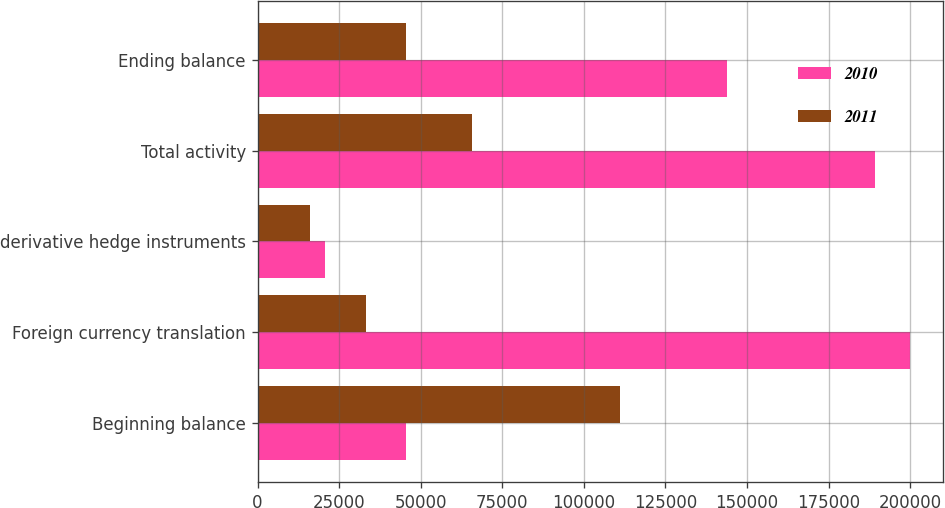Convert chart to OTSL. <chart><loc_0><loc_0><loc_500><loc_500><stacked_bar_chart><ecel><fcel>Beginning balance<fcel>Foreign currency translation<fcel>derivative hedge instruments<fcel>Total activity<fcel>Ending balance<nl><fcel>2010<fcel>45417<fcel>200121<fcel>20527<fcel>189147<fcel>143730<nl><fcel>2011<fcel>111115<fcel>33208<fcel>16179<fcel>65698<fcel>45417<nl></chart> 